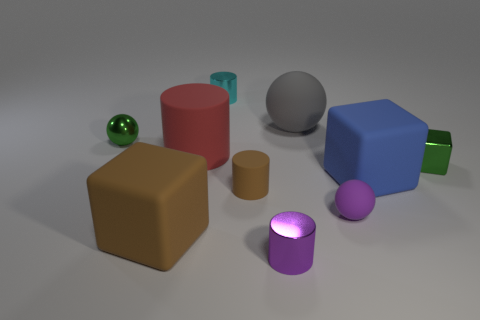Are the tiny sphere that is on the left side of the large brown matte thing and the small cylinder behind the small green shiny block made of the same material?
Your answer should be compact. Yes. What number of things are tiny purple metal cylinders or big cubes that are in front of the brown cylinder?
Provide a succinct answer. 2. The tiny thing that is the same color as the tiny rubber ball is what shape?
Your response must be concise. Cylinder. What is the green sphere made of?
Make the answer very short. Metal. Are the green sphere and the brown cylinder made of the same material?
Make the answer very short. No. How many metallic objects are either green cubes or large gray things?
Offer a terse response. 1. There is a thing that is behind the gray matte ball; what is its shape?
Your answer should be compact. Cylinder. The brown cylinder that is the same material as the gray ball is what size?
Keep it short and to the point. Small. The tiny object that is in front of the brown matte cylinder and right of the big gray matte object has what shape?
Provide a succinct answer. Sphere. Does the large block that is to the left of the purple rubber sphere have the same color as the tiny rubber cylinder?
Give a very brief answer. Yes. 